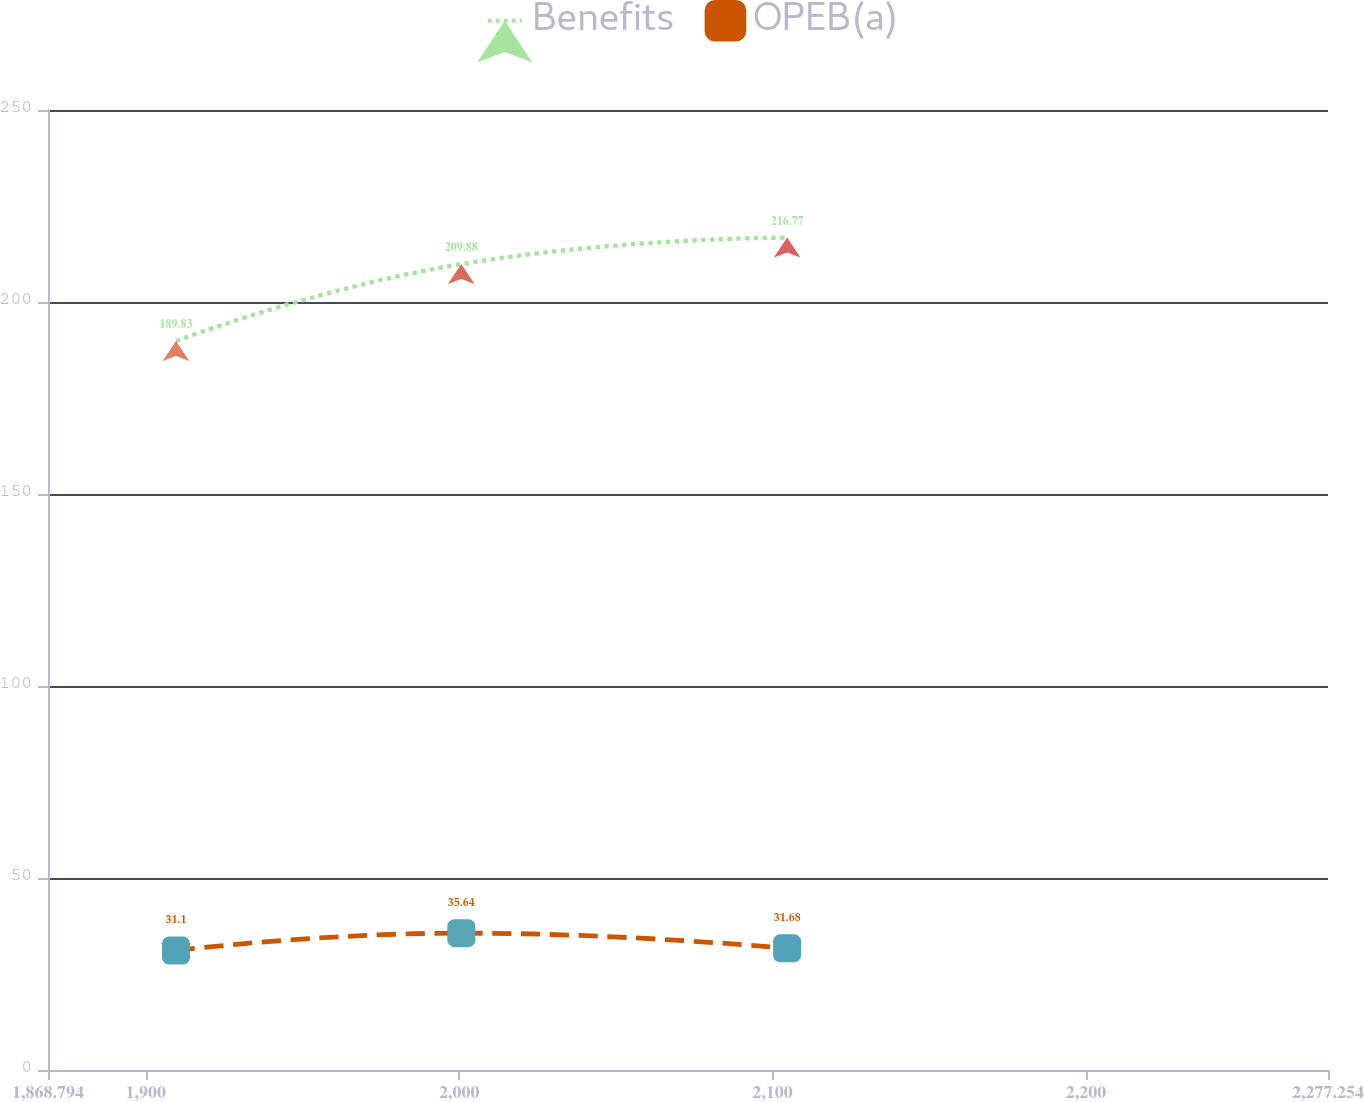<chart> <loc_0><loc_0><loc_500><loc_500><line_chart><ecel><fcel>Benefits<fcel>OPEB(a)<nl><fcel>1909.64<fcel>189.83<fcel>31.1<nl><fcel>2000.68<fcel>209.88<fcel>35.64<nl><fcel>2104.66<fcel>216.77<fcel>31.68<nl><fcel>2279.05<fcel>232.26<fcel>36.32<nl><fcel>2318.1<fcel>223.63<fcel>30.52<nl></chart> 